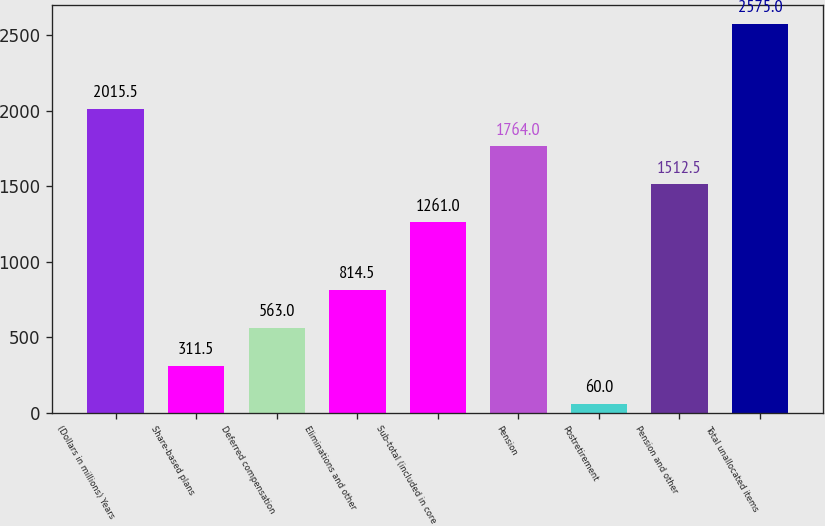Convert chart to OTSL. <chart><loc_0><loc_0><loc_500><loc_500><bar_chart><fcel>(Dollars in millions) Years<fcel>Share-based plans<fcel>Deferred compensation<fcel>Eliminations and other<fcel>Sub-total (included in core<fcel>Pension<fcel>Postretirement<fcel>Pension and other<fcel>Total unallocated items<nl><fcel>2015.5<fcel>311.5<fcel>563<fcel>814.5<fcel>1261<fcel>1764<fcel>60<fcel>1512.5<fcel>2575<nl></chart> 